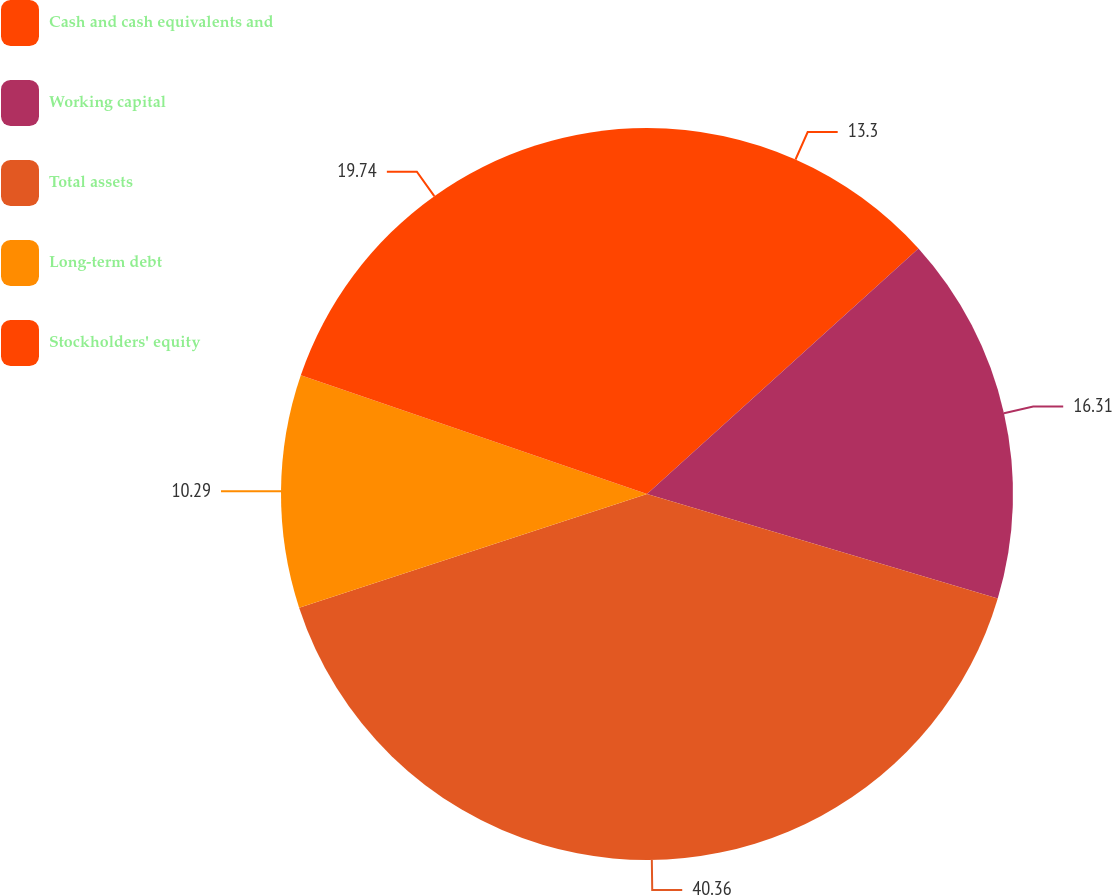Convert chart. <chart><loc_0><loc_0><loc_500><loc_500><pie_chart><fcel>Cash and cash equivalents and<fcel>Working capital<fcel>Total assets<fcel>Long-term debt<fcel>Stockholders' equity<nl><fcel>13.3%<fcel>16.31%<fcel>40.36%<fcel>10.29%<fcel>19.74%<nl></chart> 